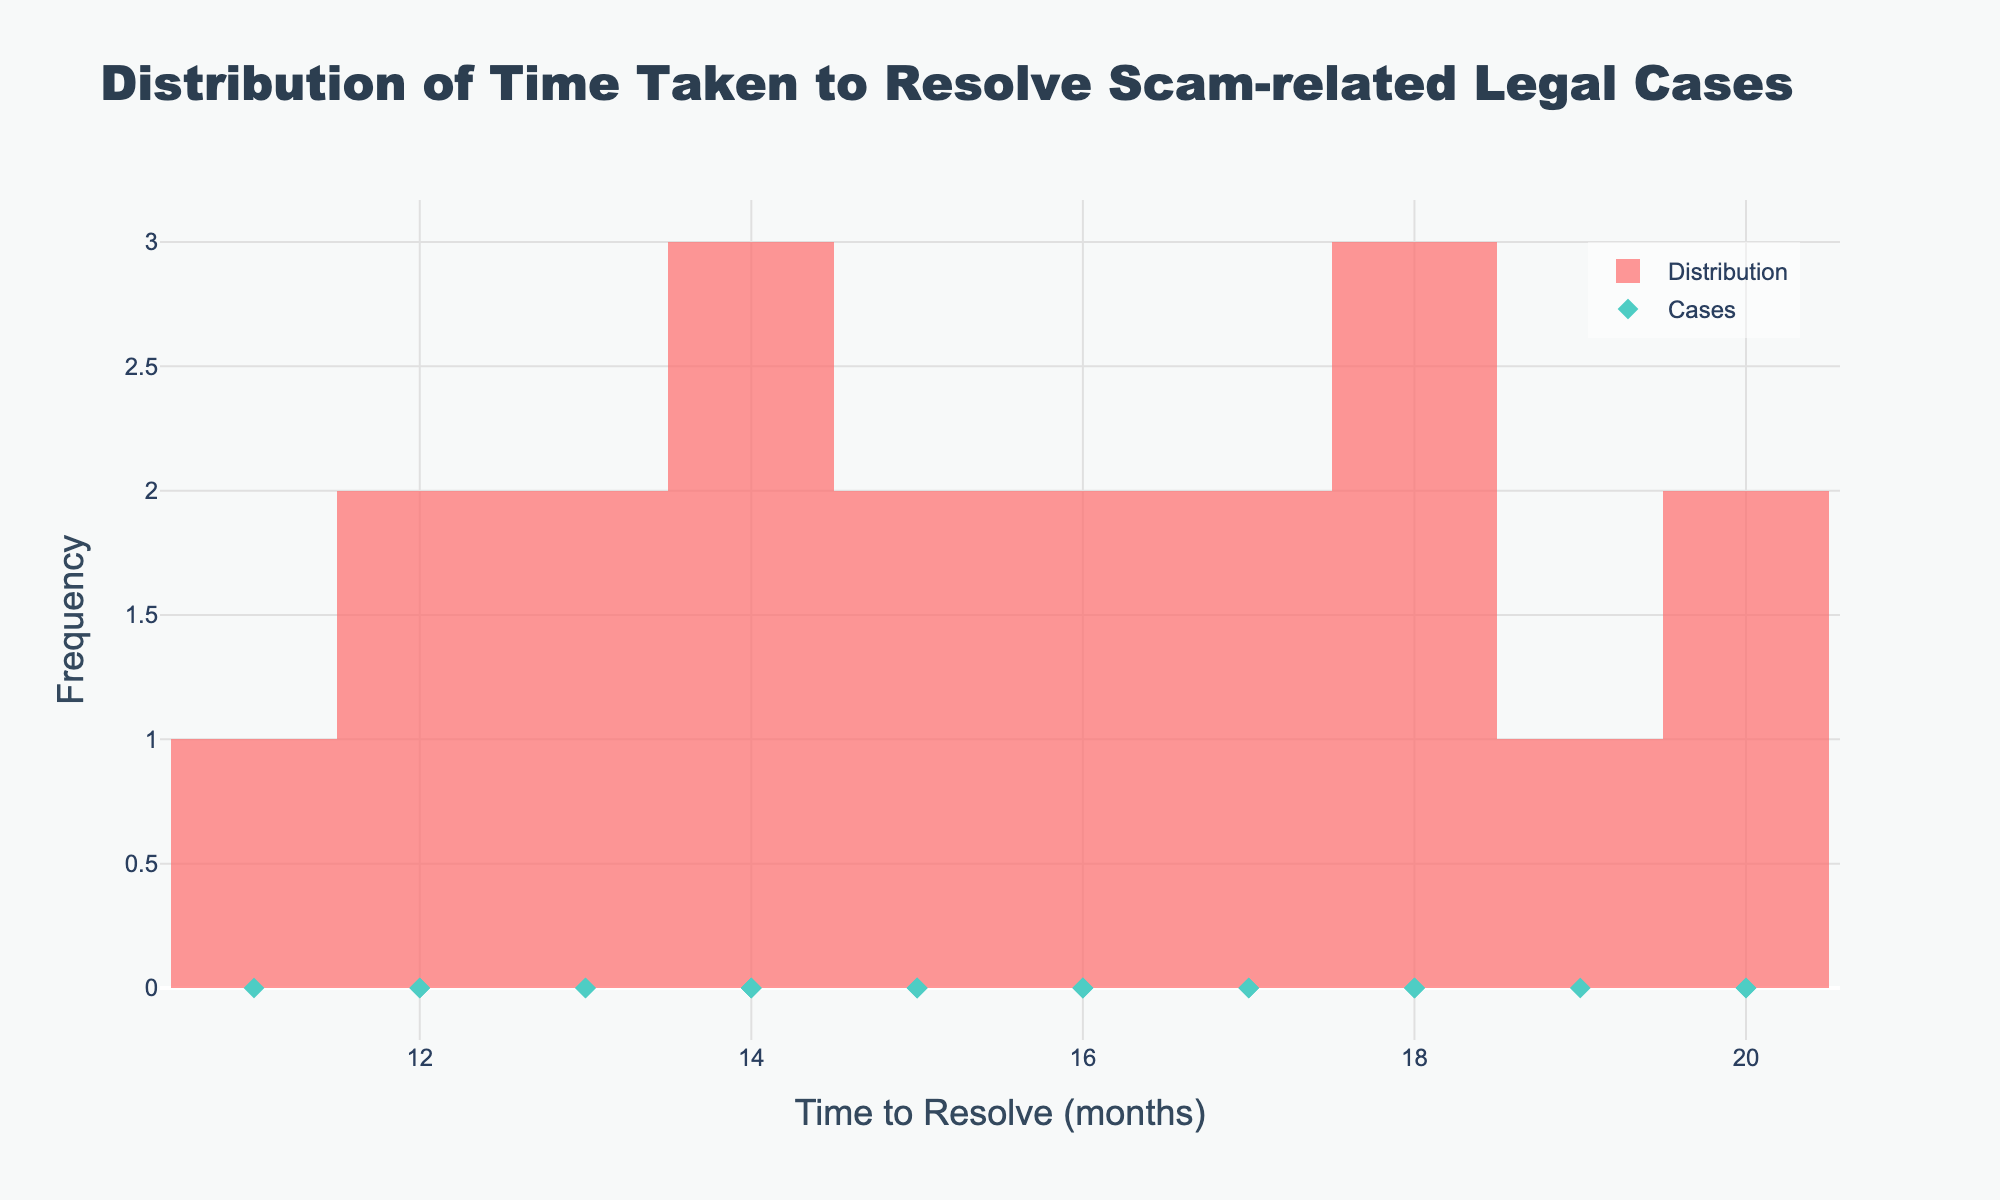What's the title of the figure? The title is located at the top of the figure, displaying the purpose or main subject of the plot.
Answer: Distribution of Time Taken to Resolve Scam-related Legal Cases What is displayed on the x-axis? The x-axis usually represents the variable being analyzed or plotted. In this case, it refers to the "Time to Resolve (months)."
Answer: Time to Resolve (months) How many distinct cases are represented in the scatter plot? By looking at the number of diamond markers (representing individual cases) in the scatter plot on the figure, we can count them one by one.
Answer: 20 What is the most frequent time range to resolve cases, based on the histogram? To determine the most frequent time range, observe the highest bar in the histogram. This signifies the bin with the maximum number of cases.
Answer: 14-16 months Which jurisdiction had the longest resolution time? Since each diamond marker in the scatter represents a case, and we can identify the longest time by finding the diamond at the far right of the x-axis. The corresponding case ID can then be matched with the jurisdiction.
Answer: Texas (20 months) What is the average time to resolve cases? Calculate the sum of all time-to-resolve values divided by the number of cases: (18 + 12 + 20 + 14 + 15 + 13 + 17 + 19 + 16 + 14 + 18 + 12 + 20 + 11 + 15 + 16 + 13 + 17 + 18 + 14) / 20.
Answer: 15.5 months How many cases took 18 months to resolve? Find the number of diamond markers or the height of the histogram bar that corresponds to the value 18 on the x-axis.
Answer: 4 cases What's the median time taken to resolve the cases? Arrange all the time-to-resolve values in ascending order and find the middle number. If there is an even number of cases, take the average of the two middle values.
Answer: 15.5 months Identify the shortest and longest time taken to resolve the cases. Look for the leftmost and rightmost diamond markers in the scatter plot to identify the shortest and longest resolution times.
Answer: Shortest: 11 months, Longest: 20 months Are there more cases resolved in less than 15 months or 15 months or more? Count the number of diamond markers (cases) less than 15 months and those 15 months or more, then compare the two counts.
Answer: Less than 15 months: 8, 15 months or more: 12 